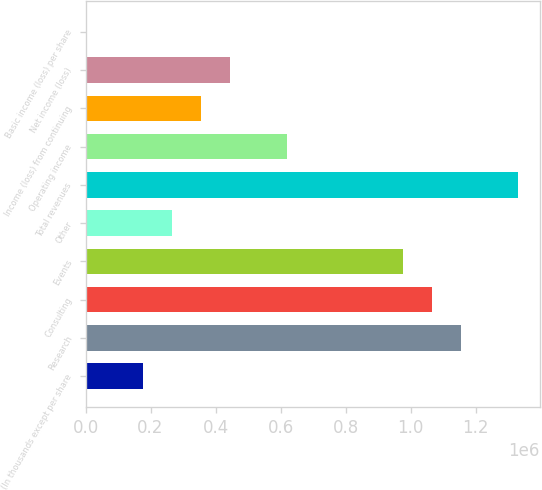Convert chart. <chart><loc_0><loc_0><loc_500><loc_500><bar_chart><fcel>(In thousands except per share<fcel>Research<fcel>Consulting<fcel>Events<fcel>Other<fcel>Total revenues<fcel>Operating income<fcel>Income (loss) from continuing<fcel>Net income (loss)<fcel>Basic income (loss) per share<nl><fcel>177519<fcel>1.15387e+06<fcel>1.06511e+06<fcel>976352<fcel>266278<fcel>1.33139e+06<fcel>621315<fcel>355037<fcel>443797<fcel>0.18<nl></chart> 